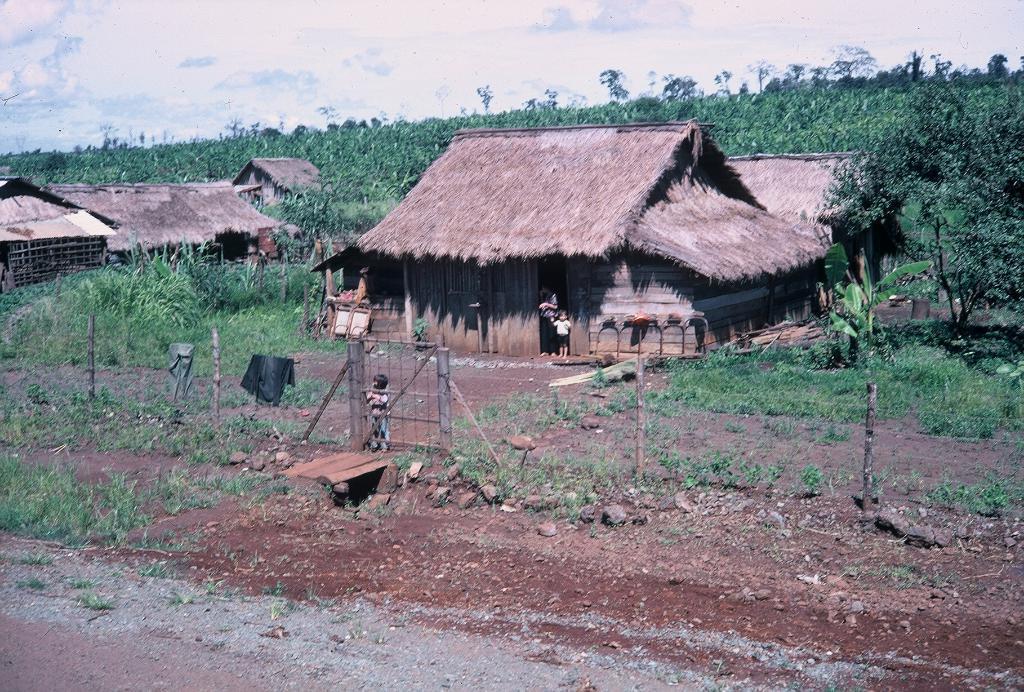How would you summarize this image in a sentence or two? At the bottom of the image on the ground there is grass and also there are small stones. There are poles with fencing and also there is a gate. Behind them there are huts with roofs, poles and walls. There are few people in the image. On the ground there is grass and also there are small plants and trees. In the background there are many trees. At the top of the image there is sky. 